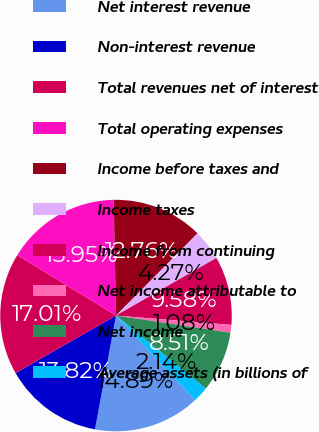<chart> <loc_0><loc_0><loc_500><loc_500><pie_chart><fcel>Net interest revenue<fcel>Non-interest revenue<fcel>Total revenues net of interest<fcel>Total operating expenses<fcel>Income before taxes and<fcel>Income taxes<fcel>Income from continuing<fcel>Net income attributable to<fcel>Net income<fcel>Average assets (in billions of<nl><fcel>14.89%<fcel>13.82%<fcel>17.01%<fcel>15.95%<fcel>12.76%<fcel>4.27%<fcel>9.58%<fcel>1.08%<fcel>8.51%<fcel>2.14%<nl></chart> 